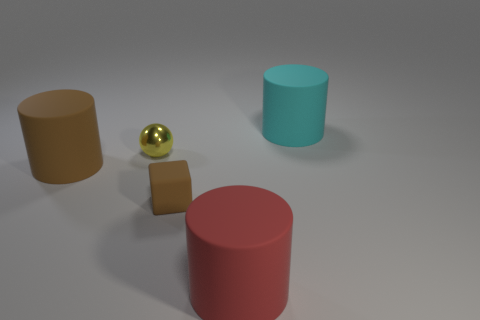Subtract all brown rubber cylinders. How many cylinders are left? 2 Add 1 yellow shiny balls. How many objects exist? 6 Subtract all red cylinders. How many cylinders are left? 2 Subtract all balls. How many objects are left? 4 Subtract 1 spheres. How many spheres are left? 0 Add 5 large cyan matte cylinders. How many large cyan matte cylinders are left? 6 Add 1 tiny yellow matte spheres. How many tiny yellow matte spheres exist? 1 Subtract 0 blue spheres. How many objects are left? 5 Subtract all blue cylinders. Subtract all yellow spheres. How many cylinders are left? 3 Subtract all blue blocks. How many brown cylinders are left? 1 